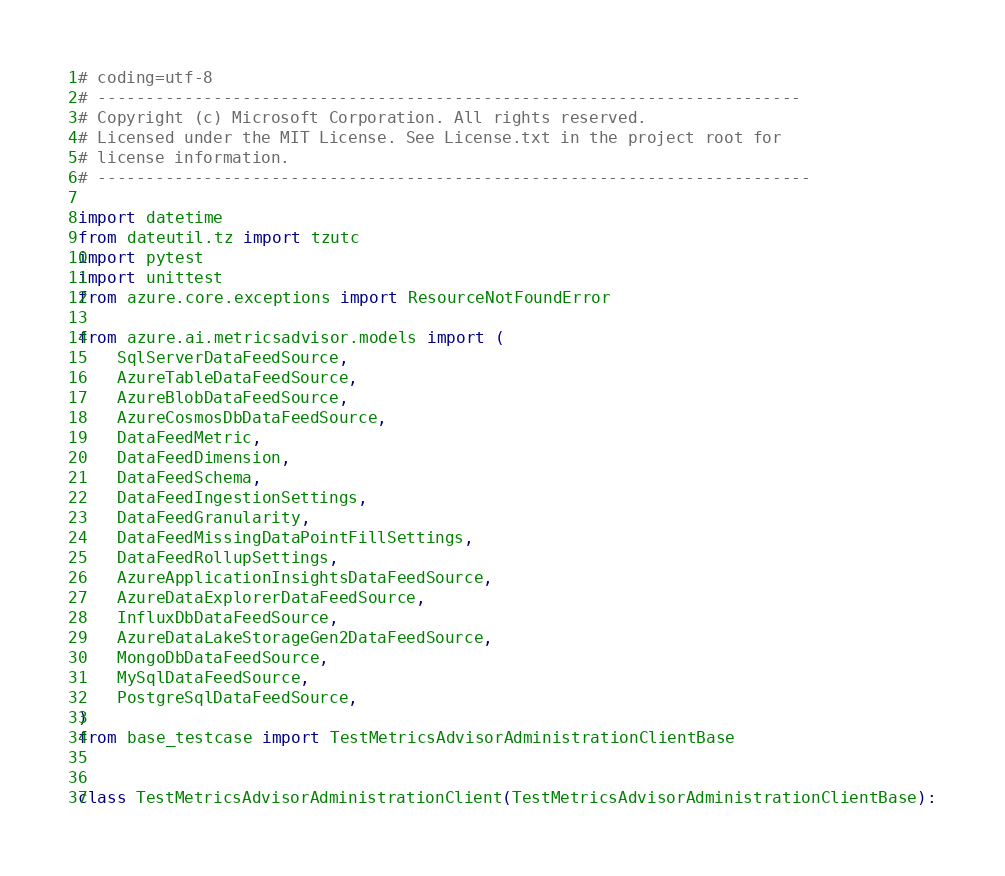<code> <loc_0><loc_0><loc_500><loc_500><_Python_># coding=utf-8
# -------------------------------------------------------------------------
# Copyright (c) Microsoft Corporation. All rights reserved.
# Licensed under the MIT License. See License.txt in the project root for
# license information.
# --------------------------------------------------------------------------

import datetime
from dateutil.tz import tzutc
import pytest
import unittest
from azure.core.exceptions import ResourceNotFoundError

from azure.ai.metricsadvisor.models import (
    SqlServerDataFeedSource,
    AzureTableDataFeedSource,
    AzureBlobDataFeedSource,
    AzureCosmosDbDataFeedSource,
    DataFeedMetric,
    DataFeedDimension,
    DataFeedSchema,
    DataFeedIngestionSettings,
    DataFeedGranularity,
    DataFeedMissingDataPointFillSettings,
    DataFeedRollupSettings,
    AzureApplicationInsightsDataFeedSource,
    AzureDataExplorerDataFeedSource,
    InfluxDbDataFeedSource,
    AzureDataLakeStorageGen2DataFeedSource,
    MongoDbDataFeedSource,
    MySqlDataFeedSource,
    PostgreSqlDataFeedSource,
)
from base_testcase import TestMetricsAdvisorAdministrationClientBase


class TestMetricsAdvisorAdministrationClient(TestMetricsAdvisorAdministrationClientBase):
</code> 